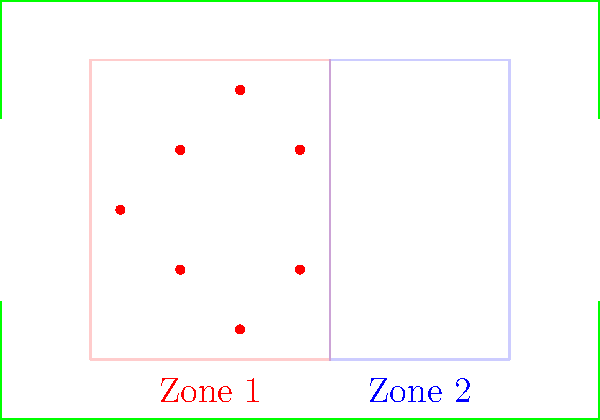In the high-pressure defensive strategy diagram shown, which zone represents the primary pressing area where the team aims to win back possession quickly? To identify the primary pressing zone in a high-pressure defensive strategy, we need to analyze the diagram step-by-step:

1. The diagram shows a soccer field with two distinct zones marked in different colors.

2. Zone 1 (red): 
   - Located in the opponent's half of the field
   - Covers a larger area
   - Contains seven defending players (red dots)

3. Zone 2 (blue):
   - Located closer to the midfield
   - Covers a smaller area
   - Contains no defending players

4. High-pressure defensive strategies typically aim to:
   - Win the ball back as quickly as possible
   - Force opponents into mistakes in their own half
   - Prevent the opposition from building attacks from the back

5. Given these principles, Zone 1 (red) is the primary pressing area because:
   - It's positioned higher up the pitch in the opponent's half
   - It contains more defending players, allowing for intense pressure
   - Its location makes it ideal for disrupting the opponent's build-up play

6. Zone 2 (blue) likely serves as a secondary pressing area or a fallback option if the initial press in Zone 1 is bypassed.

Therefore, Zone 1 (red) represents the primary pressing area where the team aims to win back possession quickly in this high-pressure defensive strategy.
Answer: Zone 1 (red zone) 